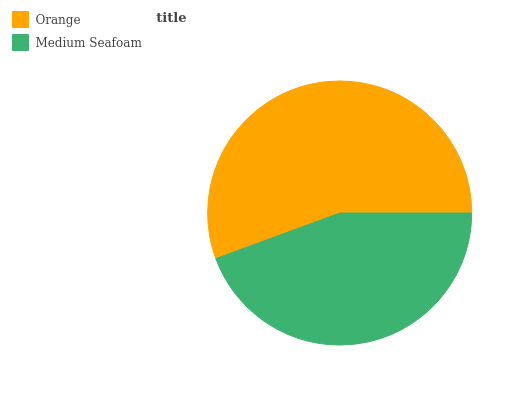Is Medium Seafoam the minimum?
Answer yes or no. Yes. Is Orange the maximum?
Answer yes or no. Yes. Is Medium Seafoam the maximum?
Answer yes or no. No. Is Orange greater than Medium Seafoam?
Answer yes or no. Yes. Is Medium Seafoam less than Orange?
Answer yes or no. Yes. Is Medium Seafoam greater than Orange?
Answer yes or no. No. Is Orange less than Medium Seafoam?
Answer yes or no. No. Is Orange the high median?
Answer yes or no. Yes. Is Medium Seafoam the low median?
Answer yes or no. Yes. Is Medium Seafoam the high median?
Answer yes or no. No. Is Orange the low median?
Answer yes or no. No. 